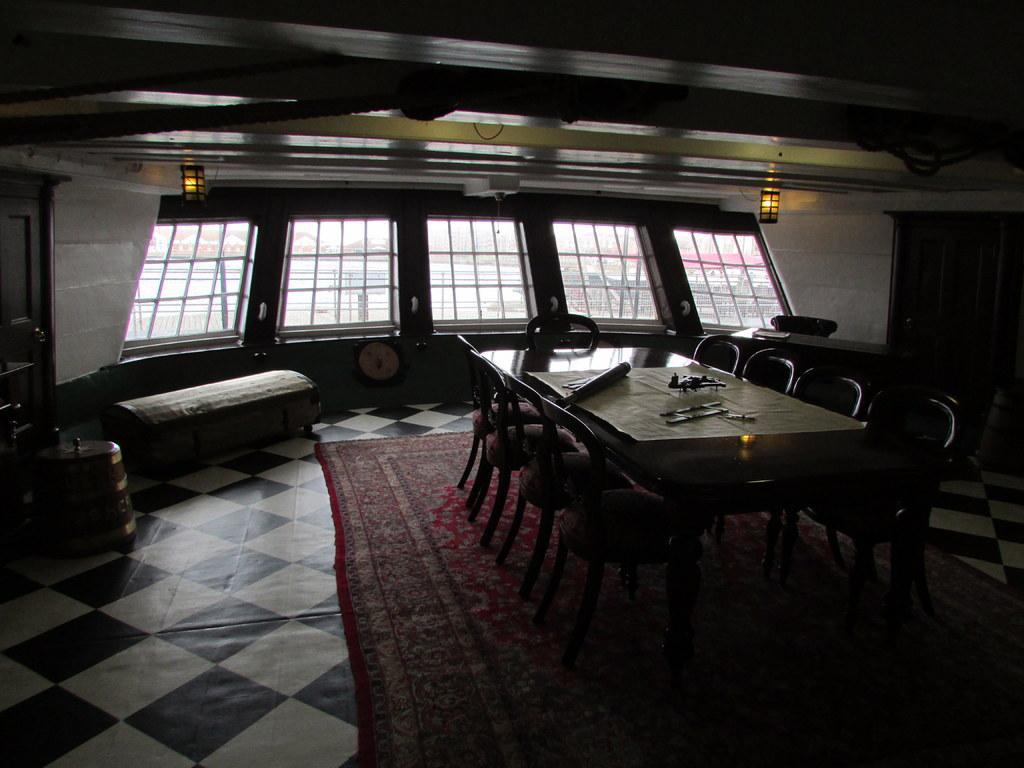In one or two sentences, can you explain what this image depicts? This is an inside view picture. In the background we can see the lights, windows and an object on the wall. We can see the chairs near to a table and on the table we can see few objects. On the right and left side of the picture we can see cupboards and few objects. At the bottom portion of the picture we can see a carpet on the floor. 